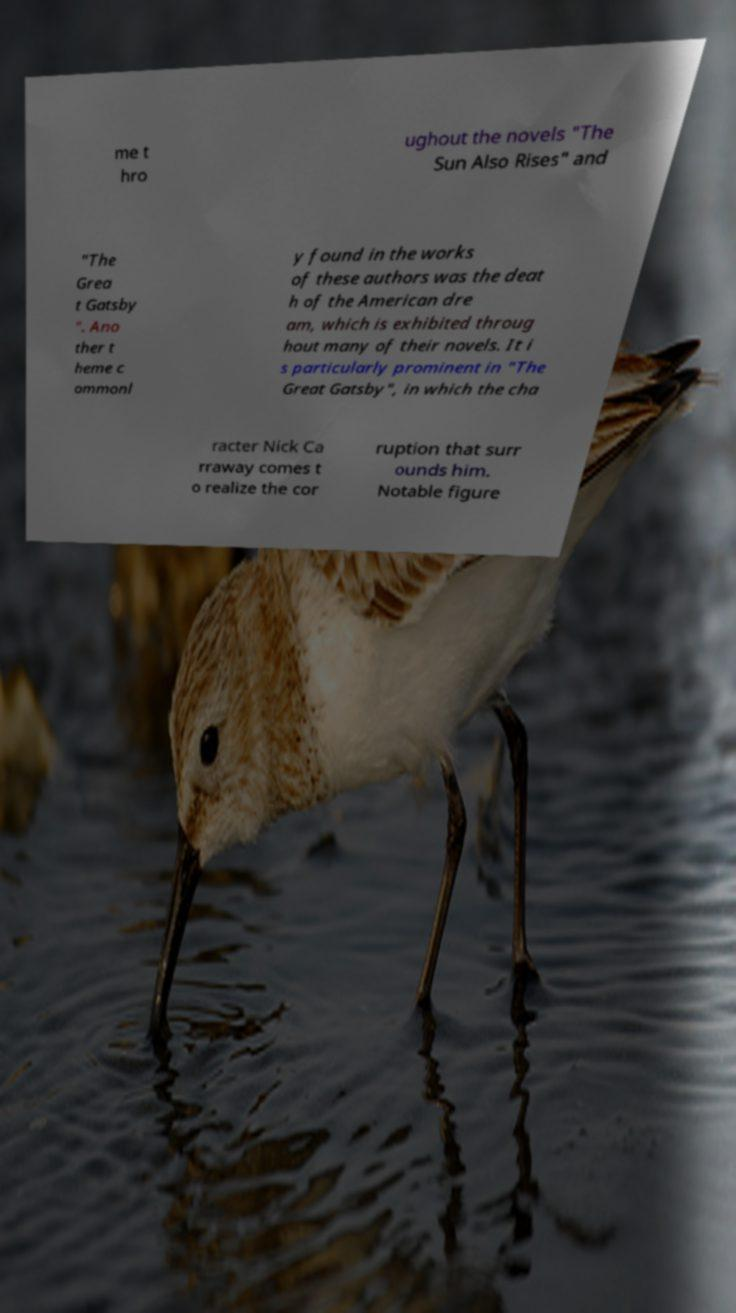Can you read and provide the text displayed in the image?This photo seems to have some interesting text. Can you extract and type it out for me? me t hro ughout the novels "The Sun Also Rises" and "The Grea t Gatsby ". Ano ther t heme c ommonl y found in the works of these authors was the deat h of the American dre am, which is exhibited throug hout many of their novels. It i s particularly prominent in "The Great Gatsby", in which the cha racter Nick Ca rraway comes t o realize the cor ruption that surr ounds him. Notable figure 